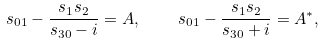<formula> <loc_0><loc_0><loc_500><loc_500>s _ { 0 1 } - \frac { s _ { 1 } s _ { 2 } } { s _ { 3 0 } - i } = A , \quad s _ { 0 1 } - \frac { s _ { 1 } s _ { 2 } } { s _ { 3 0 } + i } = A ^ { * } ,</formula> 